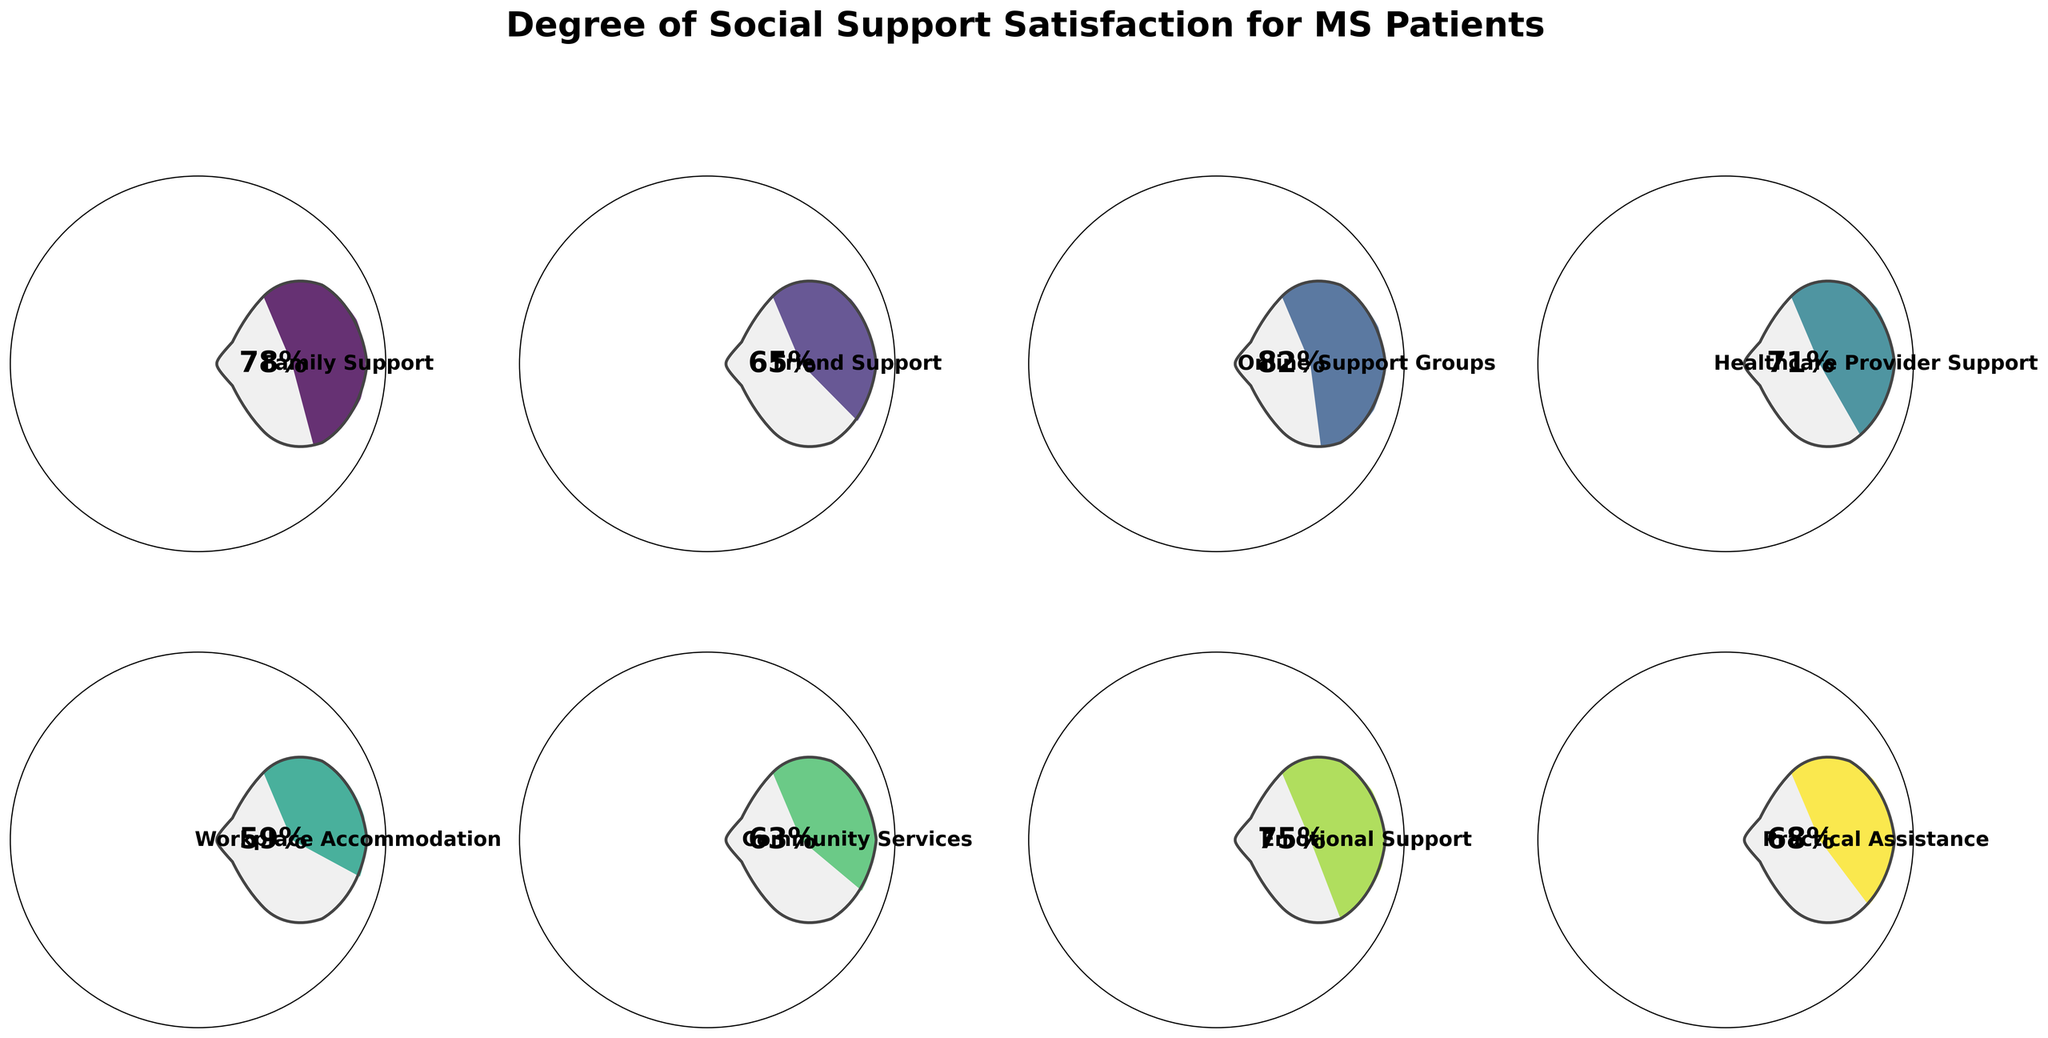What's the highest value of social support satisfaction among the categories? To find the highest value, observe the percentage labels inside each gauge. The largest percentage is the highest value of social support satisfaction. The highest value displayed is 82% for Online Support Groups.
Answer: 82% Which category has the lowest value of social support satisfaction? To determine the lowest value, compare the percentages labeled on each gauge. The smallest value displayed is 59% for Workplace Accommodation.
Answer: Workplace Accommodation What is the average value of social support satisfaction across all categories? To find the average, sum the values of all categories and divide by the number of categories. The sum is 78+65+82+71+59+63+75+68=561, and there are 8 categories; thus, the average is 561/8 = 70.125.
Answer: 70.125 How does Healthcare Provider Support compare to Family Support in terms of satisfaction? Observe the percentages for both categories. Healthcare Provider Support has 71%, and Family Support has 78%. Family Support is greater by 7%.
Answer: Family Support is greater by 7% Which categories have a satisfaction value above 70%? Look for categories with percentage labels above 70%. The categories above 70% are Family Support (78%), Online Support Groups (82%), Healthcare Provider Support (71%), and Emotional Support (75%).
Answer: Family Support, Online Support Groups, Healthcare Provider Support, Emotional Support How much higher is Emotional Support compared to Practical Assistance? Subtract the value of Practical Assistance from Emotional Support. Emotional Support is 75%, and Practical Assistance is 68%, so the difference is 75 - 68 = 7%.
Answer: 7% What's the combined satisfaction value of Community Services and Friend Support? Add the values of Community Services and Friend Support. Community Services is 63%, and Friend Support is 65%, so the combined value is 63 + 65 = 128%.
Answer: 128% How does Community Services compare to Friend Support and Practical Assistance combined? First, sum Friend Support and Practical Assistance, then compare to Community Services. Friend Support is 65%, Practical Assistance is 68%, combined they are 65 + 68 = 133%. Community Services is 63%, which is less than 133%.
Answer: Community Services is less by 70% If the values of Friend Support and Emotional Support are swapped, will the new average satisfaction level increase or decrease? Calculate the current average, then the average after swapping. Current sum is 561, with average 70.125. Swap 65 and 75, new sum is 571. With 8 categories, new average is 571/8 = 71.375, higher than the original.
Answer: Increase 